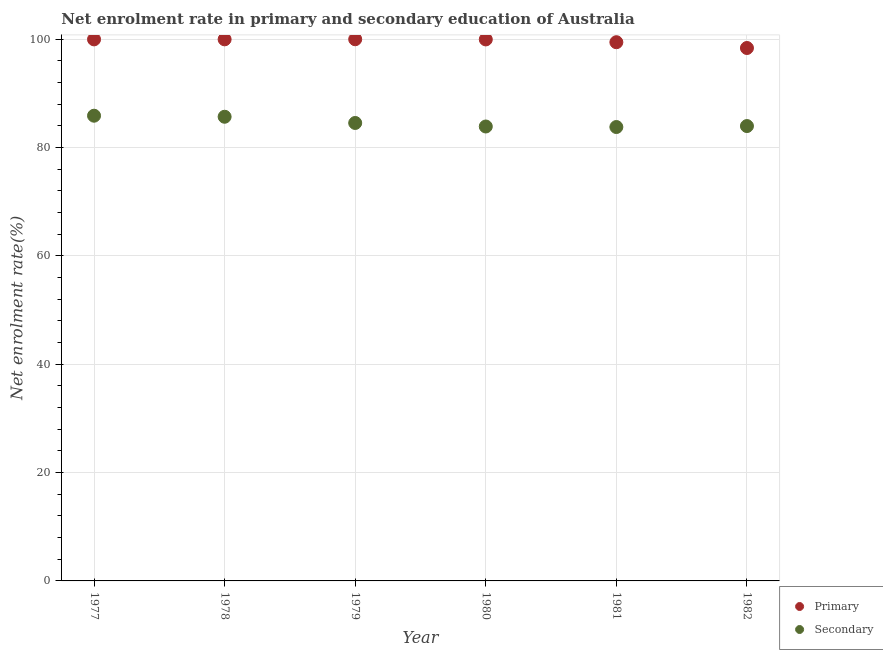What is the enrollment rate in primary education in 1978?
Keep it short and to the point. 99.97. Across all years, what is the maximum enrollment rate in secondary education?
Ensure brevity in your answer.  85.87. Across all years, what is the minimum enrollment rate in secondary education?
Give a very brief answer. 83.78. In which year was the enrollment rate in primary education minimum?
Provide a succinct answer. 1982. What is the total enrollment rate in secondary education in the graph?
Your response must be concise. 507.72. What is the difference between the enrollment rate in primary education in 1981 and that in 1982?
Provide a succinct answer. 1.07. What is the difference between the enrollment rate in primary education in 1982 and the enrollment rate in secondary education in 1978?
Give a very brief answer. 12.69. What is the average enrollment rate in primary education per year?
Keep it short and to the point. 99.61. In the year 1979, what is the difference between the enrollment rate in secondary education and enrollment rate in primary education?
Make the answer very short. -15.45. What is the ratio of the enrollment rate in secondary education in 1977 to that in 1979?
Provide a short and direct response. 1.02. Is the enrollment rate in secondary education in 1979 less than that in 1981?
Offer a very short reply. No. Is the difference between the enrollment rate in secondary education in 1977 and 1980 greater than the difference between the enrollment rate in primary education in 1977 and 1980?
Your answer should be compact. Yes. What is the difference between the highest and the second highest enrollment rate in secondary education?
Provide a short and direct response. 0.19. What is the difference between the highest and the lowest enrollment rate in secondary education?
Give a very brief answer. 2.09. Is the sum of the enrollment rate in secondary education in 1979 and 1981 greater than the maximum enrollment rate in primary education across all years?
Provide a short and direct response. Yes. What is the difference between two consecutive major ticks on the Y-axis?
Provide a succinct answer. 20. Does the graph contain any zero values?
Provide a succinct answer. No. Does the graph contain grids?
Your answer should be compact. Yes. What is the title of the graph?
Offer a terse response. Net enrolment rate in primary and secondary education of Australia. What is the label or title of the X-axis?
Ensure brevity in your answer.  Year. What is the label or title of the Y-axis?
Your answer should be very brief. Net enrolment rate(%). What is the Net enrolment rate(%) in Primary in 1977?
Offer a very short reply. 99.96. What is the Net enrolment rate(%) in Secondary in 1977?
Make the answer very short. 85.87. What is the Net enrolment rate(%) in Primary in 1978?
Your answer should be compact. 99.97. What is the Net enrolment rate(%) in Secondary in 1978?
Your answer should be very brief. 85.68. What is the Net enrolment rate(%) of Primary in 1979?
Your answer should be compact. 99.98. What is the Net enrolment rate(%) of Secondary in 1979?
Ensure brevity in your answer.  84.53. What is the Net enrolment rate(%) of Primary in 1980?
Offer a very short reply. 99.95. What is the Net enrolment rate(%) in Secondary in 1980?
Your answer should be compact. 83.88. What is the Net enrolment rate(%) in Primary in 1981?
Keep it short and to the point. 99.44. What is the Net enrolment rate(%) of Secondary in 1981?
Keep it short and to the point. 83.78. What is the Net enrolment rate(%) in Primary in 1982?
Offer a very short reply. 98.37. What is the Net enrolment rate(%) in Secondary in 1982?
Offer a terse response. 83.96. Across all years, what is the maximum Net enrolment rate(%) in Primary?
Make the answer very short. 99.98. Across all years, what is the maximum Net enrolment rate(%) in Secondary?
Make the answer very short. 85.87. Across all years, what is the minimum Net enrolment rate(%) of Primary?
Provide a succinct answer. 98.37. Across all years, what is the minimum Net enrolment rate(%) in Secondary?
Keep it short and to the point. 83.78. What is the total Net enrolment rate(%) in Primary in the graph?
Ensure brevity in your answer.  597.68. What is the total Net enrolment rate(%) of Secondary in the graph?
Keep it short and to the point. 507.72. What is the difference between the Net enrolment rate(%) in Primary in 1977 and that in 1978?
Provide a succinct answer. -0.01. What is the difference between the Net enrolment rate(%) in Secondary in 1977 and that in 1978?
Your answer should be very brief. 0.19. What is the difference between the Net enrolment rate(%) of Primary in 1977 and that in 1979?
Your answer should be very brief. -0.02. What is the difference between the Net enrolment rate(%) of Secondary in 1977 and that in 1979?
Give a very brief answer. 1.34. What is the difference between the Net enrolment rate(%) of Primary in 1977 and that in 1980?
Offer a very short reply. 0.01. What is the difference between the Net enrolment rate(%) in Secondary in 1977 and that in 1980?
Your answer should be compact. 1.99. What is the difference between the Net enrolment rate(%) in Primary in 1977 and that in 1981?
Give a very brief answer. 0.52. What is the difference between the Net enrolment rate(%) of Secondary in 1977 and that in 1981?
Provide a succinct answer. 2.09. What is the difference between the Net enrolment rate(%) in Primary in 1977 and that in 1982?
Give a very brief answer. 1.59. What is the difference between the Net enrolment rate(%) of Secondary in 1977 and that in 1982?
Provide a short and direct response. 1.91. What is the difference between the Net enrolment rate(%) in Primary in 1978 and that in 1979?
Your answer should be very brief. -0.01. What is the difference between the Net enrolment rate(%) in Secondary in 1978 and that in 1979?
Provide a succinct answer. 1.15. What is the difference between the Net enrolment rate(%) in Primary in 1978 and that in 1980?
Ensure brevity in your answer.  0.02. What is the difference between the Net enrolment rate(%) of Secondary in 1978 and that in 1980?
Provide a short and direct response. 1.8. What is the difference between the Net enrolment rate(%) of Primary in 1978 and that in 1981?
Ensure brevity in your answer.  0.53. What is the difference between the Net enrolment rate(%) of Secondary in 1978 and that in 1981?
Make the answer very short. 1.9. What is the difference between the Net enrolment rate(%) in Primary in 1978 and that in 1982?
Your answer should be very brief. 1.6. What is the difference between the Net enrolment rate(%) of Secondary in 1978 and that in 1982?
Give a very brief answer. 1.72. What is the difference between the Net enrolment rate(%) in Primary in 1979 and that in 1980?
Give a very brief answer. 0.03. What is the difference between the Net enrolment rate(%) in Secondary in 1979 and that in 1980?
Your answer should be very brief. 0.65. What is the difference between the Net enrolment rate(%) in Primary in 1979 and that in 1981?
Give a very brief answer. 0.55. What is the difference between the Net enrolment rate(%) of Secondary in 1979 and that in 1981?
Provide a short and direct response. 0.75. What is the difference between the Net enrolment rate(%) in Primary in 1979 and that in 1982?
Your response must be concise. 1.61. What is the difference between the Net enrolment rate(%) of Secondary in 1979 and that in 1982?
Your answer should be compact. 0.57. What is the difference between the Net enrolment rate(%) in Primary in 1980 and that in 1981?
Make the answer very short. 0.51. What is the difference between the Net enrolment rate(%) of Secondary in 1980 and that in 1981?
Make the answer very short. 0.1. What is the difference between the Net enrolment rate(%) of Primary in 1980 and that in 1982?
Your answer should be very brief. 1.58. What is the difference between the Net enrolment rate(%) in Secondary in 1980 and that in 1982?
Provide a succinct answer. -0.08. What is the difference between the Net enrolment rate(%) in Primary in 1981 and that in 1982?
Give a very brief answer. 1.07. What is the difference between the Net enrolment rate(%) in Secondary in 1981 and that in 1982?
Your answer should be very brief. -0.18. What is the difference between the Net enrolment rate(%) of Primary in 1977 and the Net enrolment rate(%) of Secondary in 1978?
Provide a succinct answer. 14.28. What is the difference between the Net enrolment rate(%) in Primary in 1977 and the Net enrolment rate(%) in Secondary in 1979?
Provide a succinct answer. 15.43. What is the difference between the Net enrolment rate(%) in Primary in 1977 and the Net enrolment rate(%) in Secondary in 1980?
Provide a short and direct response. 16.08. What is the difference between the Net enrolment rate(%) in Primary in 1977 and the Net enrolment rate(%) in Secondary in 1981?
Keep it short and to the point. 16.18. What is the difference between the Net enrolment rate(%) in Primary in 1977 and the Net enrolment rate(%) in Secondary in 1982?
Provide a short and direct response. 16. What is the difference between the Net enrolment rate(%) in Primary in 1978 and the Net enrolment rate(%) in Secondary in 1979?
Your answer should be very brief. 15.44. What is the difference between the Net enrolment rate(%) of Primary in 1978 and the Net enrolment rate(%) of Secondary in 1980?
Keep it short and to the point. 16.09. What is the difference between the Net enrolment rate(%) in Primary in 1978 and the Net enrolment rate(%) in Secondary in 1981?
Make the answer very short. 16.19. What is the difference between the Net enrolment rate(%) of Primary in 1978 and the Net enrolment rate(%) of Secondary in 1982?
Your answer should be very brief. 16.01. What is the difference between the Net enrolment rate(%) in Primary in 1979 and the Net enrolment rate(%) in Secondary in 1980?
Give a very brief answer. 16.1. What is the difference between the Net enrolment rate(%) in Primary in 1979 and the Net enrolment rate(%) in Secondary in 1981?
Ensure brevity in your answer.  16.2. What is the difference between the Net enrolment rate(%) in Primary in 1979 and the Net enrolment rate(%) in Secondary in 1982?
Offer a very short reply. 16.02. What is the difference between the Net enrolment rate(%) of Primary in 1980 and the Net enrolment rate(%) of Secondary in 1981?
Offer a very short reply. 16.17. What is the difference between the Net enrolment rate(%) of Primary in 1980 and the Net enrolment rate(%) of Secondary in 1982?
Offer a very short reply. 15.99. What is the difference between the Net enrolment rate(%) of Primary in 1981 and the Net enrolment rate(%) of Secondary in 1982?
Ensure brevity in your answer.  15.48. What is the average Net enrolment rate(%) of Primary per year?
Ensure brevity in your answer.  99.61. What is the average Net enrolment rate(%) of Secondary per year?
Your response must be concise. 84.62. In the year 1977, what is the difference between the Net enrolment rate(%) in Primary and Net enrolment rate(%) in Secondary?
Your answer should be compact. 14.09. In the year 1978, what is the difference between the Net enrolment rate(%) of Primary and Net enrolment rate(%) of Secondary?
Your response must be concise. 14.29. In the year 1979, what is the difference between the Net enrolment rate(%) of Primary and Net enrolment rate(%) of Secondary?
Your response must be concise. 15.45. In the year 1980, what is the difference between the Net enrolment rate(%) in Primary and Net enrolment rate(%) in Secondary?
Ensure brevity in your answer.  16.07. In the year 1981, what is the difference between the Net enrolment rate(%) of Primary and Net enrolment rate(%) of Secondary?
Keep it short and to the point. 15.65. In the year 1982, what is the difference between the Net enrolment rate(%) of Primary and Net enrolment rate(%) of Secondary?
Your answer should be compact. 14.41. What is the ratio of the Net enrolment rate(%) of Secondary in 1977 to that in 1978?
Provide a short and direct response. 1. What is the ratio of the Net enrolment rate(%) in Primary in 1977 to that in 1979?
Make the answer very short. 1. What is the ratio of the Net enrolment rate(%) of Secondary in 1977 to that in 1979?
Give a very brief answer. 1.02. What is the ratio of the Net enrolment rate(%) in Primary in 1977 to that in 1980?
Your answer should be compact. 1. What is the ratio of the Net enrolment rate(%) of Secondary in 1977 to that in 1980?
Your answer should be compact. 1.02. What is the ratio of the Net enrolment rate(%) in Primary in 1977 to that in 1981?
Give a very brief answer. 1.01. What is the ratio of the Net enrolment rate(%) of Secondary in 1977 to that in 1981?
Your response must be concise. 1.02. What is the ratio of the Net enrolment rate(%) of Primary in 1977 to that in 1982?
Your answer should be compact. 1.02. What is the ratio of the Net enrolment rate(%) of Secondary in 1977 to that in 1982?
Your answer should be very brief. 1.02. What is the ratio of the Net enrolment rate(%) of Primary in 1978 to that in 1979?
Offer a terse response. 1. What is the ratio of the Net enrolment rate(%) in Secondary in 1978 to that in 1979?
Give a very brief answer. 1.01. What is the ratio of the Net enrolment rate(%) in Secondary in 1978 to that in 1980?
Provide a short and direct response. 1.02. What is the ratio of the Net enrolment rate(%) of Primary in 1978 to that in 1981?
Offer a terse response. 1.01. What is the ratio of the Net enrolment rate(%) in Secondary in 1978 to that in 1981?
Your answer should be very brief. 1.02. What is the ratio of the Net enrolment rate(%) of Primary in 1978 to that in 1982?
Give a very brief answer. 1.02. What is the ratio of the Net enrolment rate(%) of Secondary in 1978 to that in 1982?
Provide a short and direct response. 1.02. What is the ratio of the Net enrolment rate(%) of Primary in 1979 to that in 1981?
Provide a short and direct response. 1.01. What is the ratio of the Net enrolment rate(%) in Secondary in 1979 to that in 1981?
Provide a succinct answer. 1.01. What is the ratio of the Net enrolment rate(%) of Primary in 1979 to that in 1982?
Make the answer very short. 1.02. What is the ratio of the Net enrolment rate(%) in Secondary in 1979 to that in 1982?
Your response must be concise. 1.01. What is the ratio of the Net enrolment rate(%) of Secondary in 1980 to that in 1981?
Offer a very short reply. 1. What is the ratio of the Net enrolment rate(%) in Primary in 1980 to that in 1982?
Your response must be concise. 1.02. What is the ratio of the Net enrolment rate(%) in Primary in 1981 to that in 1982?
Your response must be concise. 1.01. What is the difference between the highest and the second highest Net enrolment rate(%) in Primary?
Your response must be concise. 0.01. What is the difference between the highest and the second highest Net enrolment rate(%) in Secondary?
Offer a very short reply. 0.19. What is the difference between the highest and the lowest Net enrolment rate(%) of Primary?
Your response must be concise. 1.61. What is the difference between the highest and the lowest Net enrolment rate(%) of Secondary?
Offer a terse response. 2.09. 